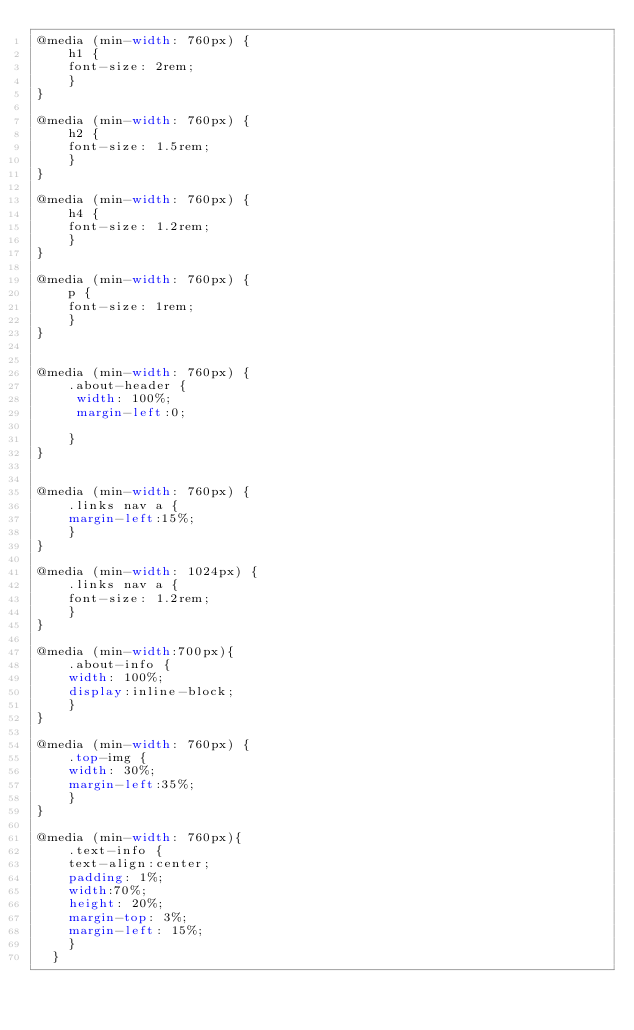Convert code to text. <code><loc_0><loc_0><loc_500><loc_500><_CSS_>@media (min-width: 760px) {
    h1 {
    font-size: 2rem;
    }
}

@media (min-width: 760px) {
    h2 {
    font-size: 1.5rem;
    }
}

@media (min-width: 760px) {
    h4 {
    font-size: 1.2rem;
    }
}

@media (min-width: 760px) {
    p {
    font-size: 1rem;
    }
}


@media (min-width: 760px) {
    .about-header {
     width: 100%;
     margin-left:0;

    }
}


@media (min-width: 760px) {
    .links nav a {
    margin-left:15%;
    }
}

@media (min-width: 1024px) {
    .links nav a {
    font-size: 1.2rem;
    }
}

@media (min-width:700px){
    .about-info {
    width: 100%;
    display:inline-block;
    }
}

@media (min-width: 760px) {
    .top-img {
    width: 30%;
    margin-left:35%;
    }
}

@media (min-width: 760px){
    .text-info {
    text-align:center;
    padding: 1%;
    width:70%;
    height: 20%;
    margin-top: 3%;
    margin-left: 15%;
    }
  }
</code> 